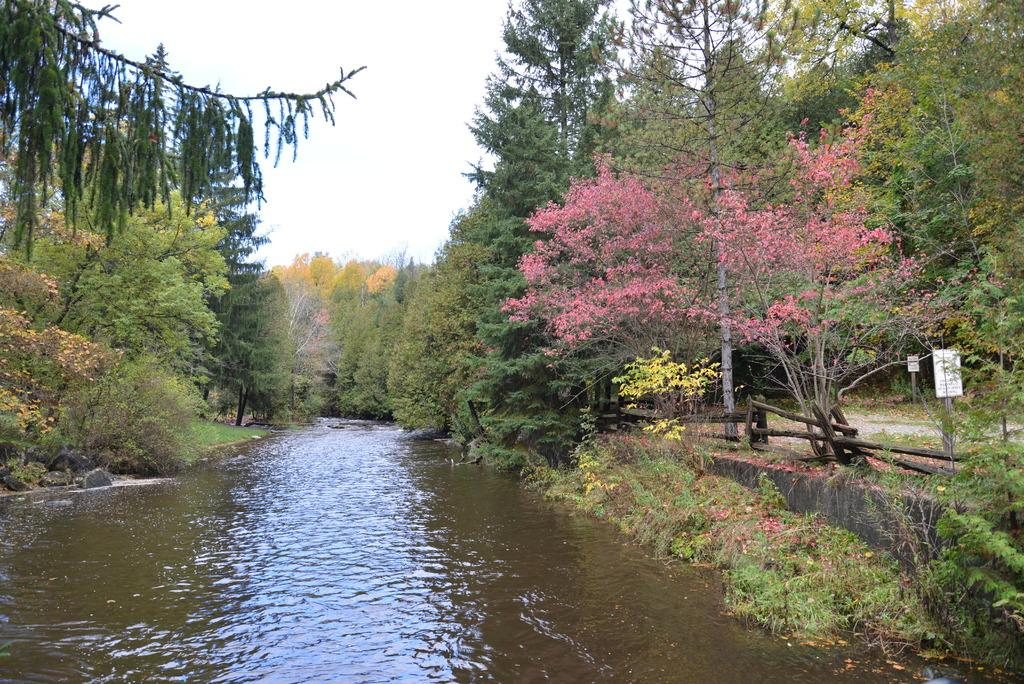What type of natural elements can be seen in the image? There are many trees and plants in the image. What type of materials are used for the objects in the image? There are wooden objects in the image. What type of structures can be seen in the image? There are poles and boards in the image. What type of man-made surface is visible in the image? There is a road in the image. What type of body of water is visible in the image? There is water visible at the bottom of the image. What part of the natural environment is visible in the background of the image? The sky is visible in the background of the image. Can you hear the sound of thunder in the image? There is no sound present in the image, so it is not possible to hear thunder. What type of grip is used by the plants in the image? Plants do not have grips; they have roots that anchor them to the ground. 